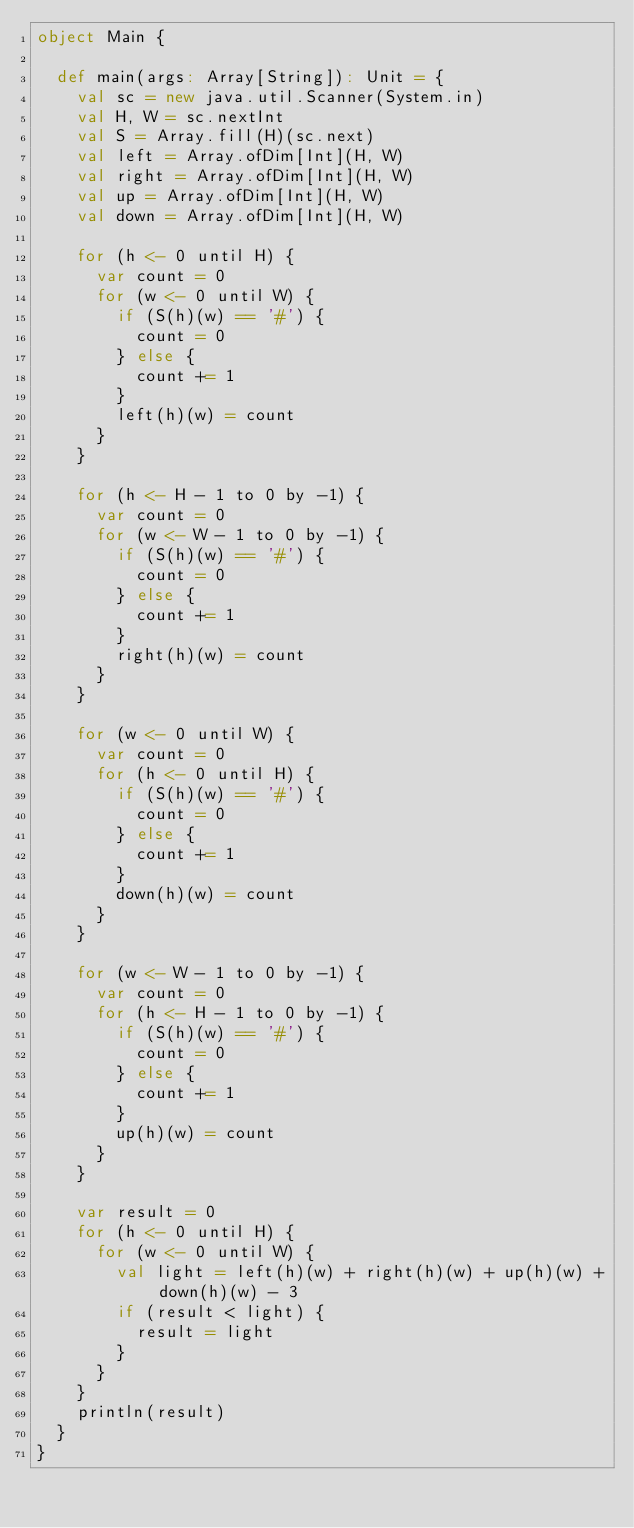<code> <loc_0><loc_0><loc_500><loc_500><_Scala_>object Main {

  def main(args: Array[String]): Unit = {
    val sc = new java.util.Scanner(System.in)
    val H, W = sc.nextInt
    val S = Array.fill(H)(sc.next)
    val left = Array.ofDim[Int](H, W)
    val right = Array.ofDim[Int](H, W)
    val up = Array.ofDim[Int](H, W)
    val down = Array.ofDim[Int](H, W)

    for (h <- 0 until H) {
      var count = 0
      for (w <- 0 until W) {
        if (S(h)(w) == '#') {
          count = 0
        } else {
          count += 1
        }
        left(h)(w) = count
      }
    }

    for (h <- H - 1 to 0 by -1) {
      var count = 0
      for (w <- W - 1 to 0 by -1) {
        if (S(h)(w) == '#') {
          count = 0
        } else {
          count += 1
        }
        right(h)(w) = count
      }
    }

    for (w <- 0 until W) {
      var count = 0
      for (h <- 0 until H) {
        if (S(h)(w) == '#') {
          count = 0
        } else {
          count += 1
        }
        down(h)(w) = count
      }
    }

    for (w <- W - 1 to 0 by -1) {
      var count = 0
      for (h <- H - 1 to 0 by -1) {
        if (S(h)(w) == '#') {
          count = 0
        } else {
          count += 1
        }
        up(h)(w) = count
      }
    }

    var result = 0
    for (h <- 0 until H) {
      for (w <- 0 until W) {
        val light = left(h)(w) + right(h)(w) + up(h)(w) + down(h)(w) - 3
        if (result < light) {
          result = light
        }
      }
    }
    println(result)
  }
}</code> 